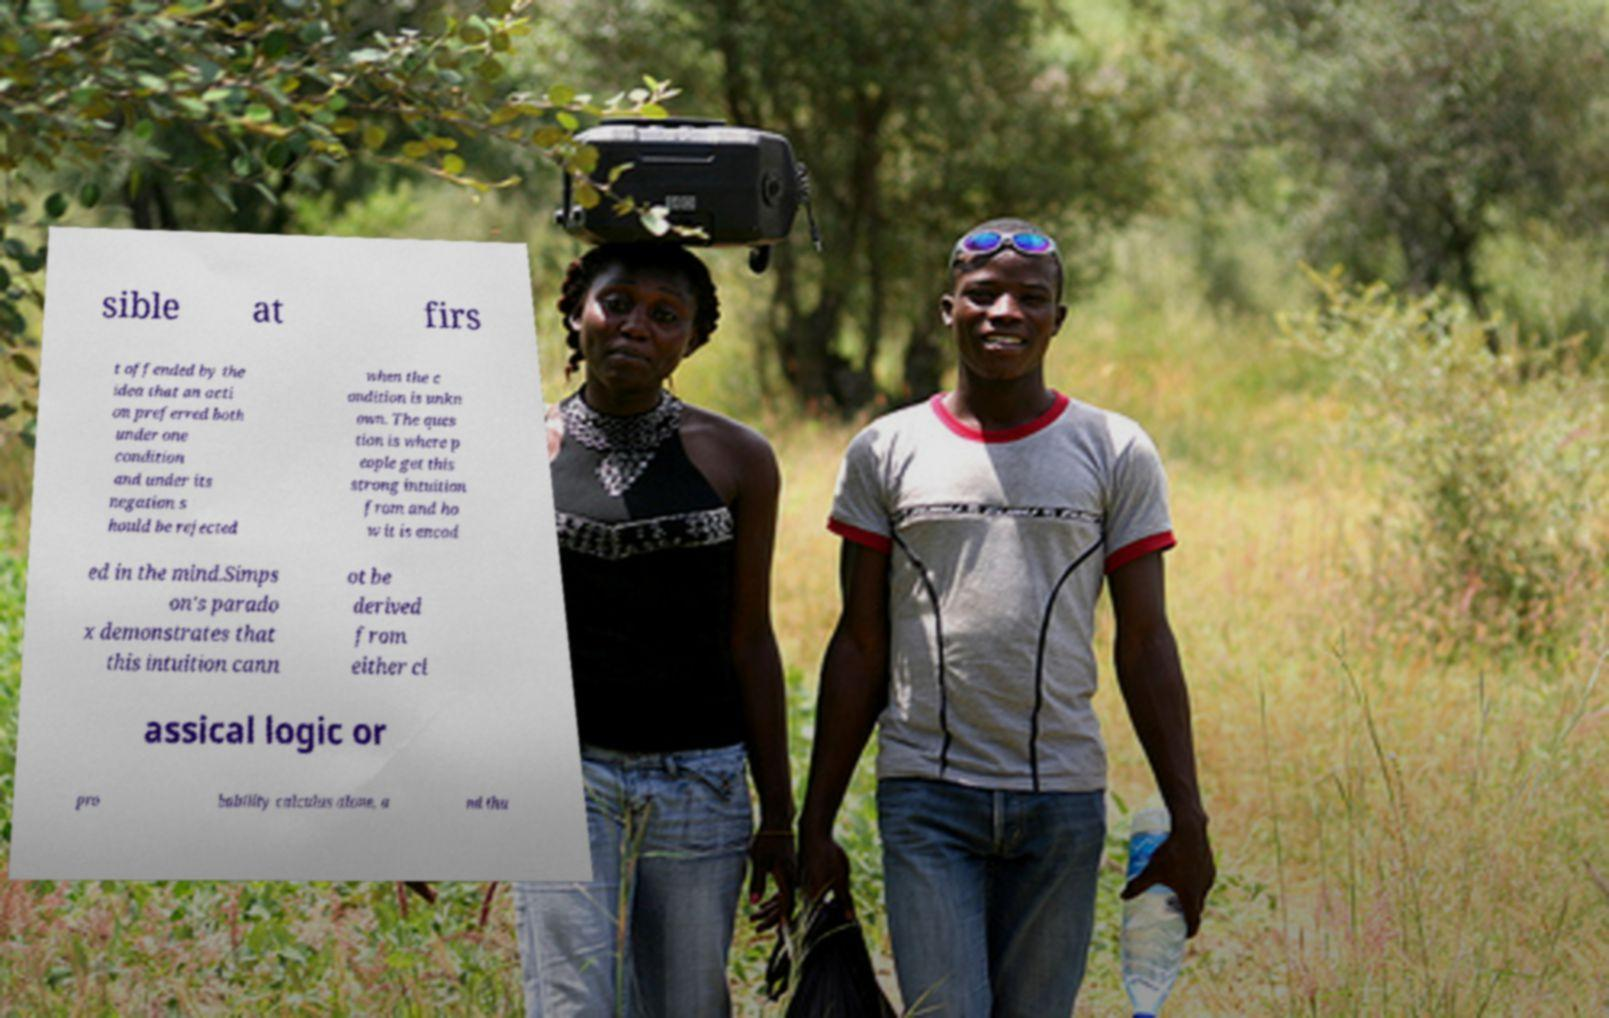Please identify and transcribe the text found in this image. sible at firs t offended by the idea that an acti on preferred both under one condition and under its negation s hould be rejected when the c ondition is unkn own. The ques tion is where p eople get this strong intuition from and ho w it is encod ed in the mind.Simps on's parado x demonstrates that this intuition cann ot be derived from either cl assical logic or pro bability calculus alone, a nd thu 